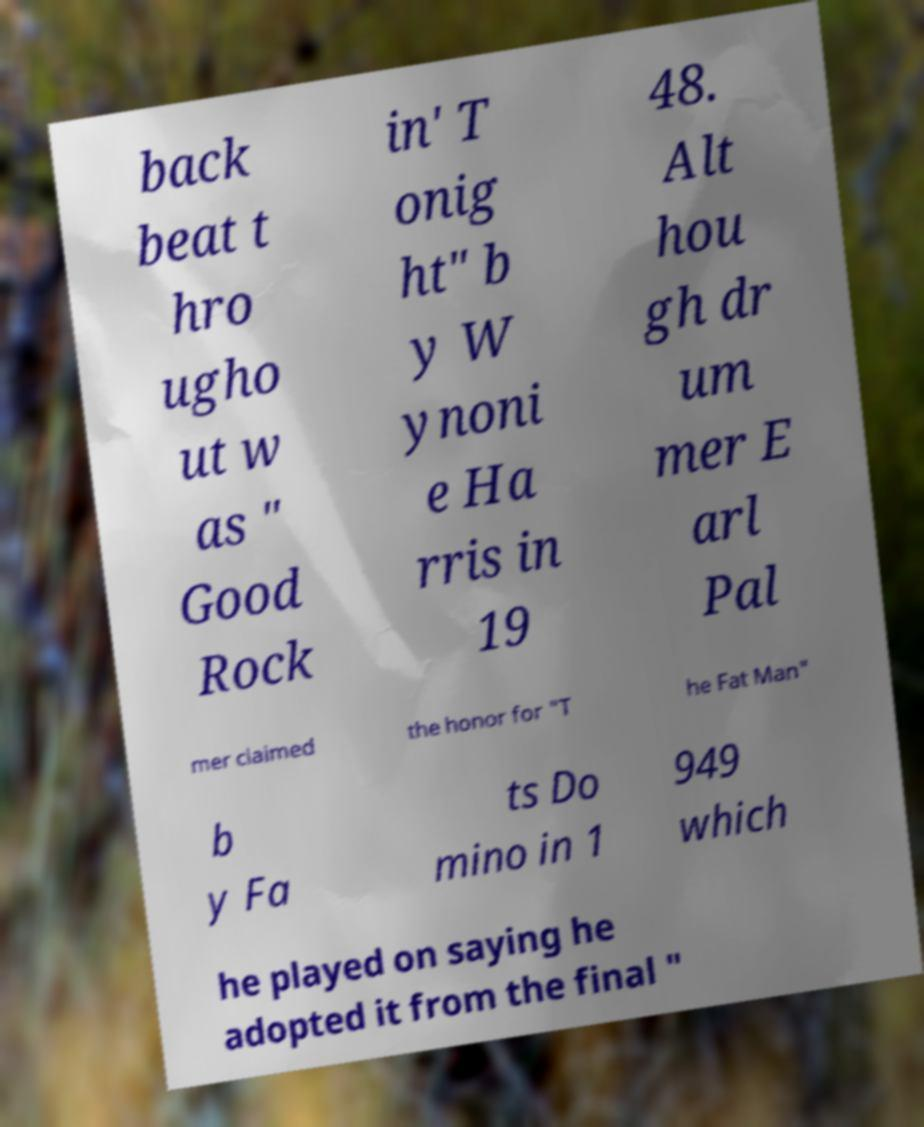Can you read and provide the text displayed in the image?This photo seems to have some interesting text. Can you extract and type it out for me? back beat t hro ugho ut w as " Good Rock in' T onig ht" b y W ynoni e Ha rris in 19 48. Alt hou gh dr um mer E arl Pal mer claimed the honor for "T he Fat Man" b y Fa ts Do mino in 1 949 which he played on saying he adopted it from the final " 